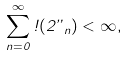<formula> <loc_0><loc_0><loc_500><loc_500>\sum _ { n = 0 } ^ { \infty } \omega ( 2 \varepsilon _ { n } ) < \infty ,</formula> 